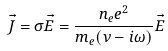Convert formula to latex. <formula><loc_0><loc_0><loc_500><loc_500>\vec { J } = \sigma \vec { E } = \frac { n _ { e } e ^ { 2 } } { m _ { e } ( \nu - i \omega ) } \vec { E }</formula> 